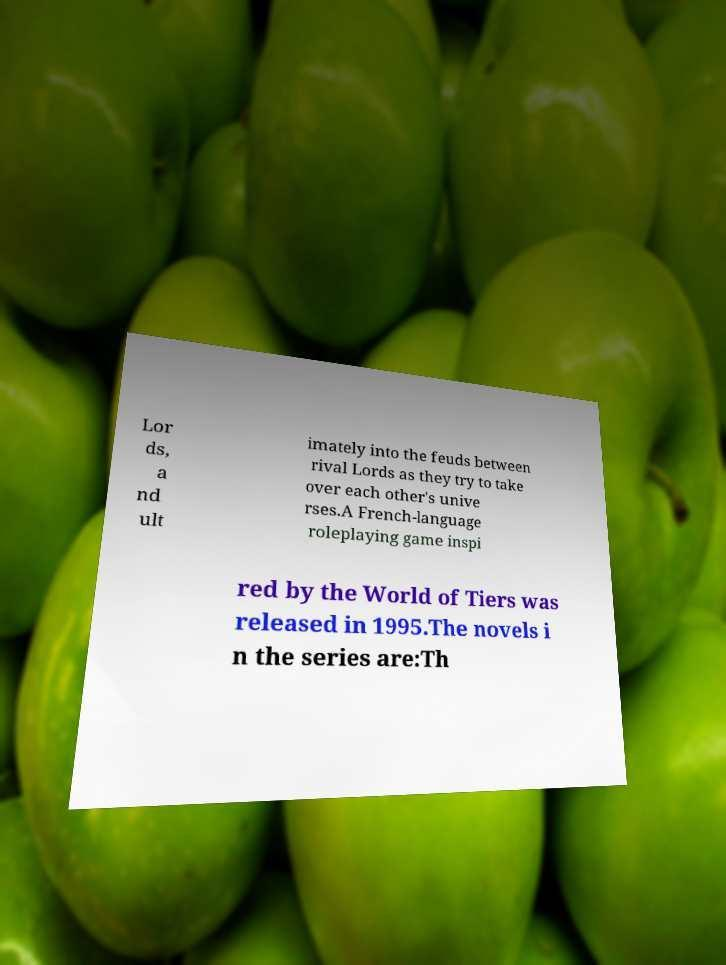Could you extract and type out the text from this image? Lor ds, a nd ult imately into the feuds between rival Lords as they try to take over each other's unive rses.A French-language roleplaying game inspi red by the World of Tiers was released in 1995.The novels i n the series are:Th 